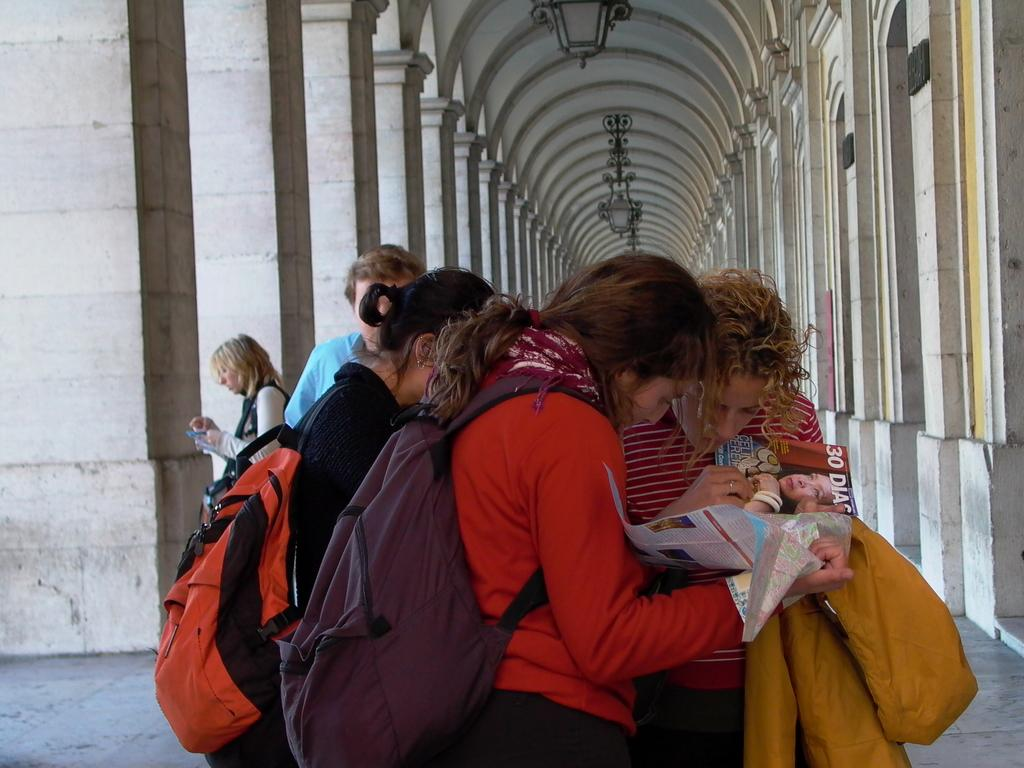What is happening in the foreground of the image? There are people standing in the foreground of the image. Can you describe the girl in the image? There is a girl in the middle of the group, and she is wearing a bag. What type of guitar is the stranger playing in the image? There is no stranger or guitar present in the image. 